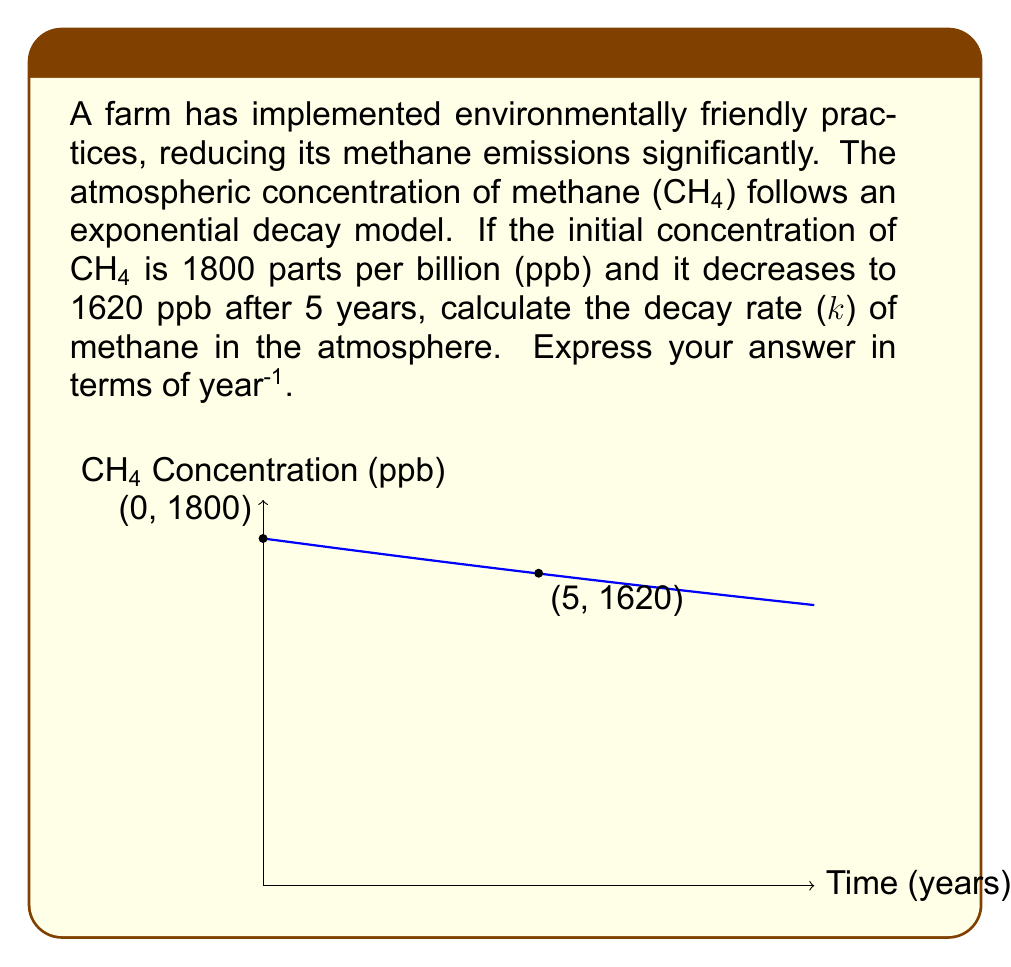Show me your answer to this math problem. To solve this problem, we'll use the exponential decay model:

$$C(t) = C_0 e^{-kt}$$

Where:
$C(t)$ is the concentration at time $t$
$C_0$ is the initial concentration
$k$ is the decay rate
$t$ is time

We know:
$C_0 = 1800$ ppb
$C(5) = 1620$ ppb
$t = 5$ years

Let's substitute these values into the equation:

$$1620 = 1800 e^{-k(5)}$$

Now, let's solve for $k$:

1) Divide both sides by 1800:
   $$\frac{1620}{1800} = e^{-5k}$$

2) Take the natural logarithm of both sides:
   $$\ln(\frac{1620}{1800}) = \ln(e^{-5k})$$
   $$\ln(\frac{1620}{1800}) = -5k$$

3) Solve for $k$:
   $$k = -\frac{1}{5}\ln(\frac{1620}{1800})$$

4) Calculate the value:
   $$k = -\frac{1}{5}\ln(0.9) \approx 0.0213$$

Therefore, the decay rate $k$ is approximately 0.0213 year⁻¹.
Answer: $k \approx 0.0213$ year⁻¹ 